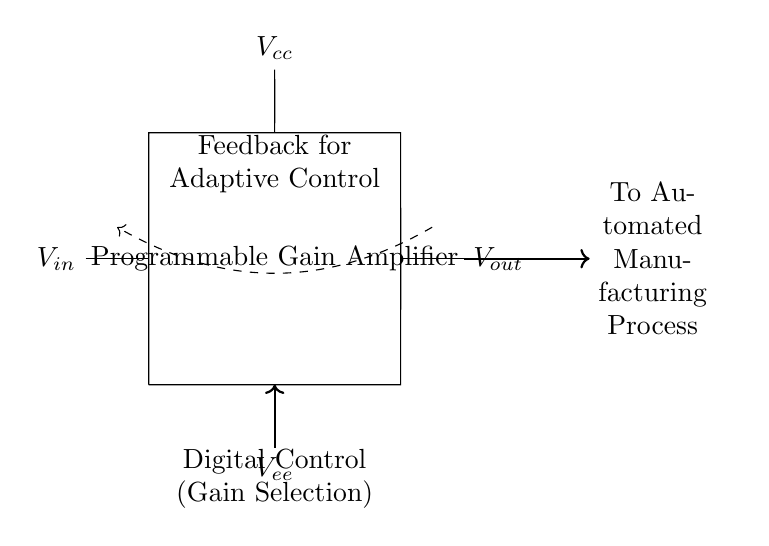What is the function of the component labeled "Programmable Gain Amplifier"? The component amplifies the input signal by a gain that can be adjusted programmatically, allowing for flexible control over the output voltage based on varying input conditions.
Answer: Programmable Gain Amplifier What does "Digital Control (Gain Selection)" indicate in the circuit? This section represents a control mechanism that allows the gain of the amplifier to be adjusted digitally, meaning the gain can be set or modified through a digital interface or programming.
Answer: Gain Selection What are the power supply voltages indicated in the circuit? The circuit has two power supplies: one labeled Vcc (positive) and another labeled Vee (negative), which provide the necessary operating voltages for the amplifier.
Answer: Vcc and Vee What type of control does the "Feedback for Adaptive Control" provide? The feedback loop allows the output of the amplifier to influence its behavior, enabling the circuit to adapt to changes in the manufacturing process by adjusting the gain based on the feedback received.
Answer: Adaptive Control How does the output of the amplifier relate to the automated manufacturing process? The output voltage, labeled Vout, is directly sent to the automated manufacturing process, indicating that the amplifier is part of a larger control system that influences production based on electrical signals.
Answer: To Automated Manufacturing Process What could be the advantage of using a Programmable Gain Amplifier in manufacturing? The advantage lies in its ability to adapt dynamically to changes in signal conditions, allowing for optimized performance and potentially improving output and reducing costs in automation.
Answer: Dynamic Adaptability 